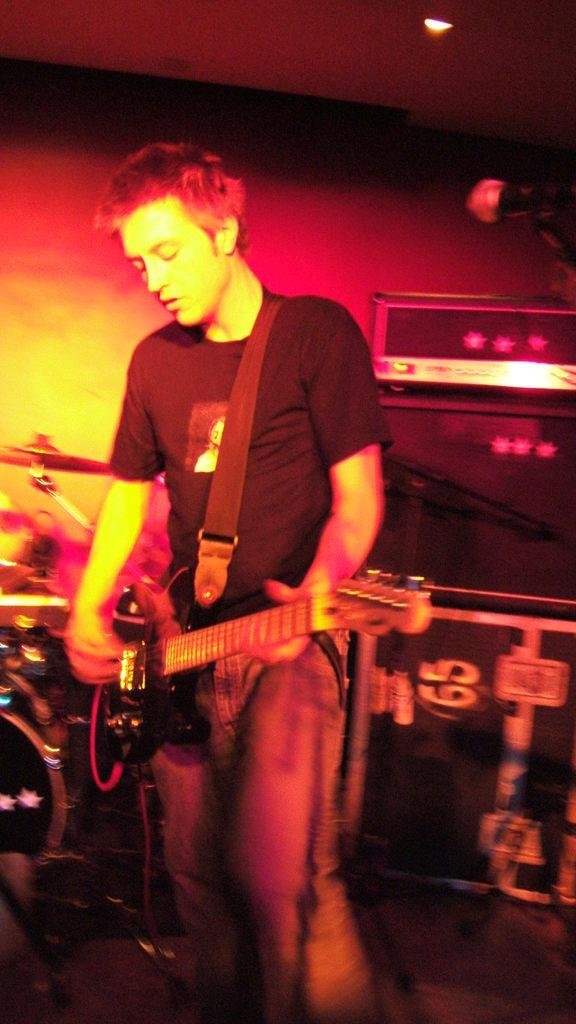What is the person in the image doing? The person is standing in the image and holding a guitar. What else can be seen in the image related to music? There are musical instruments in the background. Can you describe the lighting in the image? There is a light visible at the top of the image. What word is being spelled out by the knife in the image? There is no knife present in the image, so no word can be spelled out by a knife. 